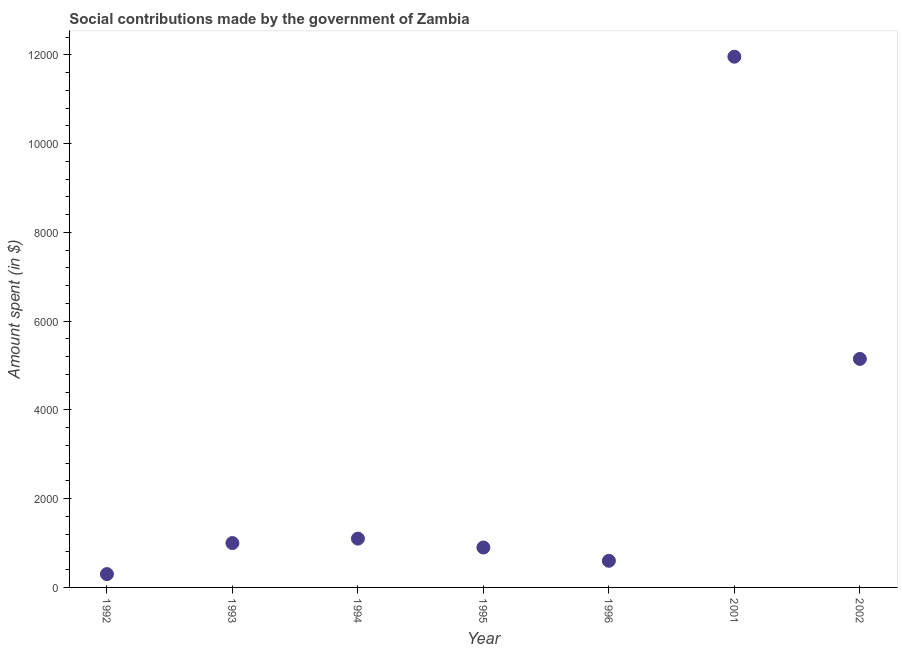What is the amount spent in making social contributions in 2001?
Offer a terse response. 1.20e+04. Across all years, what is the maximum amount spent in making social contributions?
Your answer should be very brief. 1.20e+04. Across all years, what is the minimum amount spent in making social contributions?
Provide a short and direct response. 300. In which year was the amount spent in making social contributions minimum?
Your answer should be compact. 1992. What is the sum of the amount spent in making social contributions?
Offer a terse response. 2.10e+04. What is the difference between the amount spent in making social contributions in 1992 and 1996?
Ensure brevity in your answer.  -300. What is the average amount spent in making social contributions per year?
Give a very brief answer. 3001.5. In how many years, is the amount spent in making social contributions greater than 2400 $?
Your response must be concise. 2. What is the ratio of the amount spent in making social contributions in 1992 to that in 1994?
Your answer should be compact. 0.27. Is the amount spent in making social contributions in 1992 less than that in 1994?
Keep it short and to the point. Yes. Is the difference between the amount spent in making social contributions in 1994 and 2001 greater than the difference between any two years?
Offer a very short reply. No. What is the difference between the highest and the second highest amount spent in making social contributions?
Keep it short and to the point. 6810.51. Is the sum of the amount spent in making social contributions in 1992 and 1994 greater than the maximum amount spent in making social contributions across all years?
Ensure brevity in your answer.  No. What is the difference between the highest and the lowest amount spent in making social contributions?
Provide a short and direct response. 1.17e+04. In how many years, is the amount spent in making social contributions greater than the average amount spent in making social contributions taken over all years?
Provide a succinct answer. 2. What is the difference between two consecutive major ticks on the Y-axis?
Provide a short and direct response. 2000. Are the values on the major ticks of Y-axis written in scientific E-notation?
Provide a short and direct response. No. Does the graph contain grids?
Your answer should be very brief. No. What is the title of the graph?
Give a very brief answer. Social contributions made by the government of Zambia. What is the label or title of the Y-axis?
Make the answer very short. Amount spent (in $). What is the Amount spent (in $) in 1992?
Keep it short and to the point. 300. What is the Amount spent (in $) in 1994?
Ensure brevity in your answer.  1100. What is the Amount spent (in $) in 1995?
Offer a terse response. 900. What is the Amount spent (in $) in 1996?
Your response must be concise. 600. What is the Amount spent (in $) in 2001?
Offer a very short reply. 1.20e+04. What is the Amount spent (in $) in 2002?
Offer a very short reply. 5150. What is the difference between the Amount spent (in $) in 1992 and 1993?
Provide a succinct answer. -700. What is the difference between the Amount spent (in $) in 1992 and 1994?
Your response must be concise. -800. What is the difference between the Amount spent (in $) in 1992 and 1995?
Offer a terse response. -600. What is the difference between the Amount spent (in $) in 1992 and 1996?
Make the answer very short. -300. What is the difference between the Amount spent (in $) in 1992 and 2001?
Your response must be concise. -1.17e+04. What is the difference between the Amount spent (in $) in 1992 and 2002?
Ensure brevity in your answer.  -4850. What is the difference between the Amount spent (in $) in 1993 and 1994?
Make the answer very short. -100. What is the difference between the Amount spent (in $) in 1993 and 1996?
Your response must be concise. 400. What is the difference between the Amount spent (in $) in 1993 and 2001?
Provide a short and direct response. -1.10e+04. What is the difference between the Amount spent (in $) in 1993 and 2002?
Provide a short and direct response. -4150. What is the difference between the Amount spent (in $) in 1994 and 1995?
Provide a short and direct response. 200. What is the difference between the Amount spent (in $) in 1994 and 2001?
Ensure brevity in your answer.  -1.09e+04. What is the difference between the Amount spent (in $) in 1994 and 2002?
Give a very brief answer. -4050. What is the difference between the Amount spent (in $) in 1995 and 1996?
Ensure brevity in your answer.  300. What is the difference between the Amount spent (in $) in 1995 and 2001?
Provide a short and direct response. -1.11e+04. What is the difference between the Amount spent (in $) in 1995 and 2002?
Provide a short and direct response. -4250. What is the difference between the Amount spent (in $) in 1996 and 2001?
Offer a terse response. -1.14e+04. What is the difference between the Amount spent (in $) in 1996 and 2002?
Provide a short and direct response. -4550. What is the difference between the Amount spent (in $) in 2001 and 2002?
Give a very brief answer. 6810.51. What is the ratio of the Amount spent (in $) in 1992 to that in 1994?
Ensure brevity in your answer.  0.27. What is the ratio of the Amount spent (in $) in 1992 to that in 1995?
Make the answer very short. 0.33. What is the ratio of the Amount spent (in $) in 1992 to that in 2001?
Offer a very short reply. 0.03. What is the ratio of the Amount spent (in $) in 1992 to that in 2002?
Make the answer very short. 0.06. What is the ratio of the Amount spent (in $) in 1993 to that in 1994?
Offer a very short reply. 0.91. What is the ratio of the Amount spent (in $) in 1993 to that in 1995?
Offer a terse response. 1.11. What is the ratio of the Amount spent (in $) in 1993 to that in 1996?
Offer a very short reply. 1.67. What is the ratio of the Amount spent (in $) in 1993 to that in 2001?
Your answer should be very brief. 0.08. What is the ratio of the Amount spent (in $) in 1993 to that in 2002?
Provide a short and direct response. 0.19. What is the ratio of the Amount spent (in $) in 1994 to that in 1995?
Your answer should be compact. 1.22. What is the ratio of the Amount spent (in $) in 1994 to that in 1996?
Keep it short and to the point. 1.83. What is the ratio of the Amount spent (in $) in 1994 to that in 2001?
Your answer should be compact. 0.09. What is the ratio of the Amount spent (in $) in 1994 to that in 2002?
Give a very brief answer. 0.21. What is the ratio of the Amount spent (in $) in 1995 to that in 1996?
Make the answer very short. 1.5. What is the ratio of the Amount spent (in $) in 1995 to that in 2001?
Offer a very short reply. 0.07. What is the ratio of the Amount spent (in $) in 1995 to that in 2002?
Your answer should be compact. 0.17. What is the ratio of the Amount spent (in $) in 1996 to that in 2002?
Provide a short and direct response. 0.12. What is the ratio of the Amount spent (in $) in 2001 to that in 2002?
Your response must be concise. 2.32. 